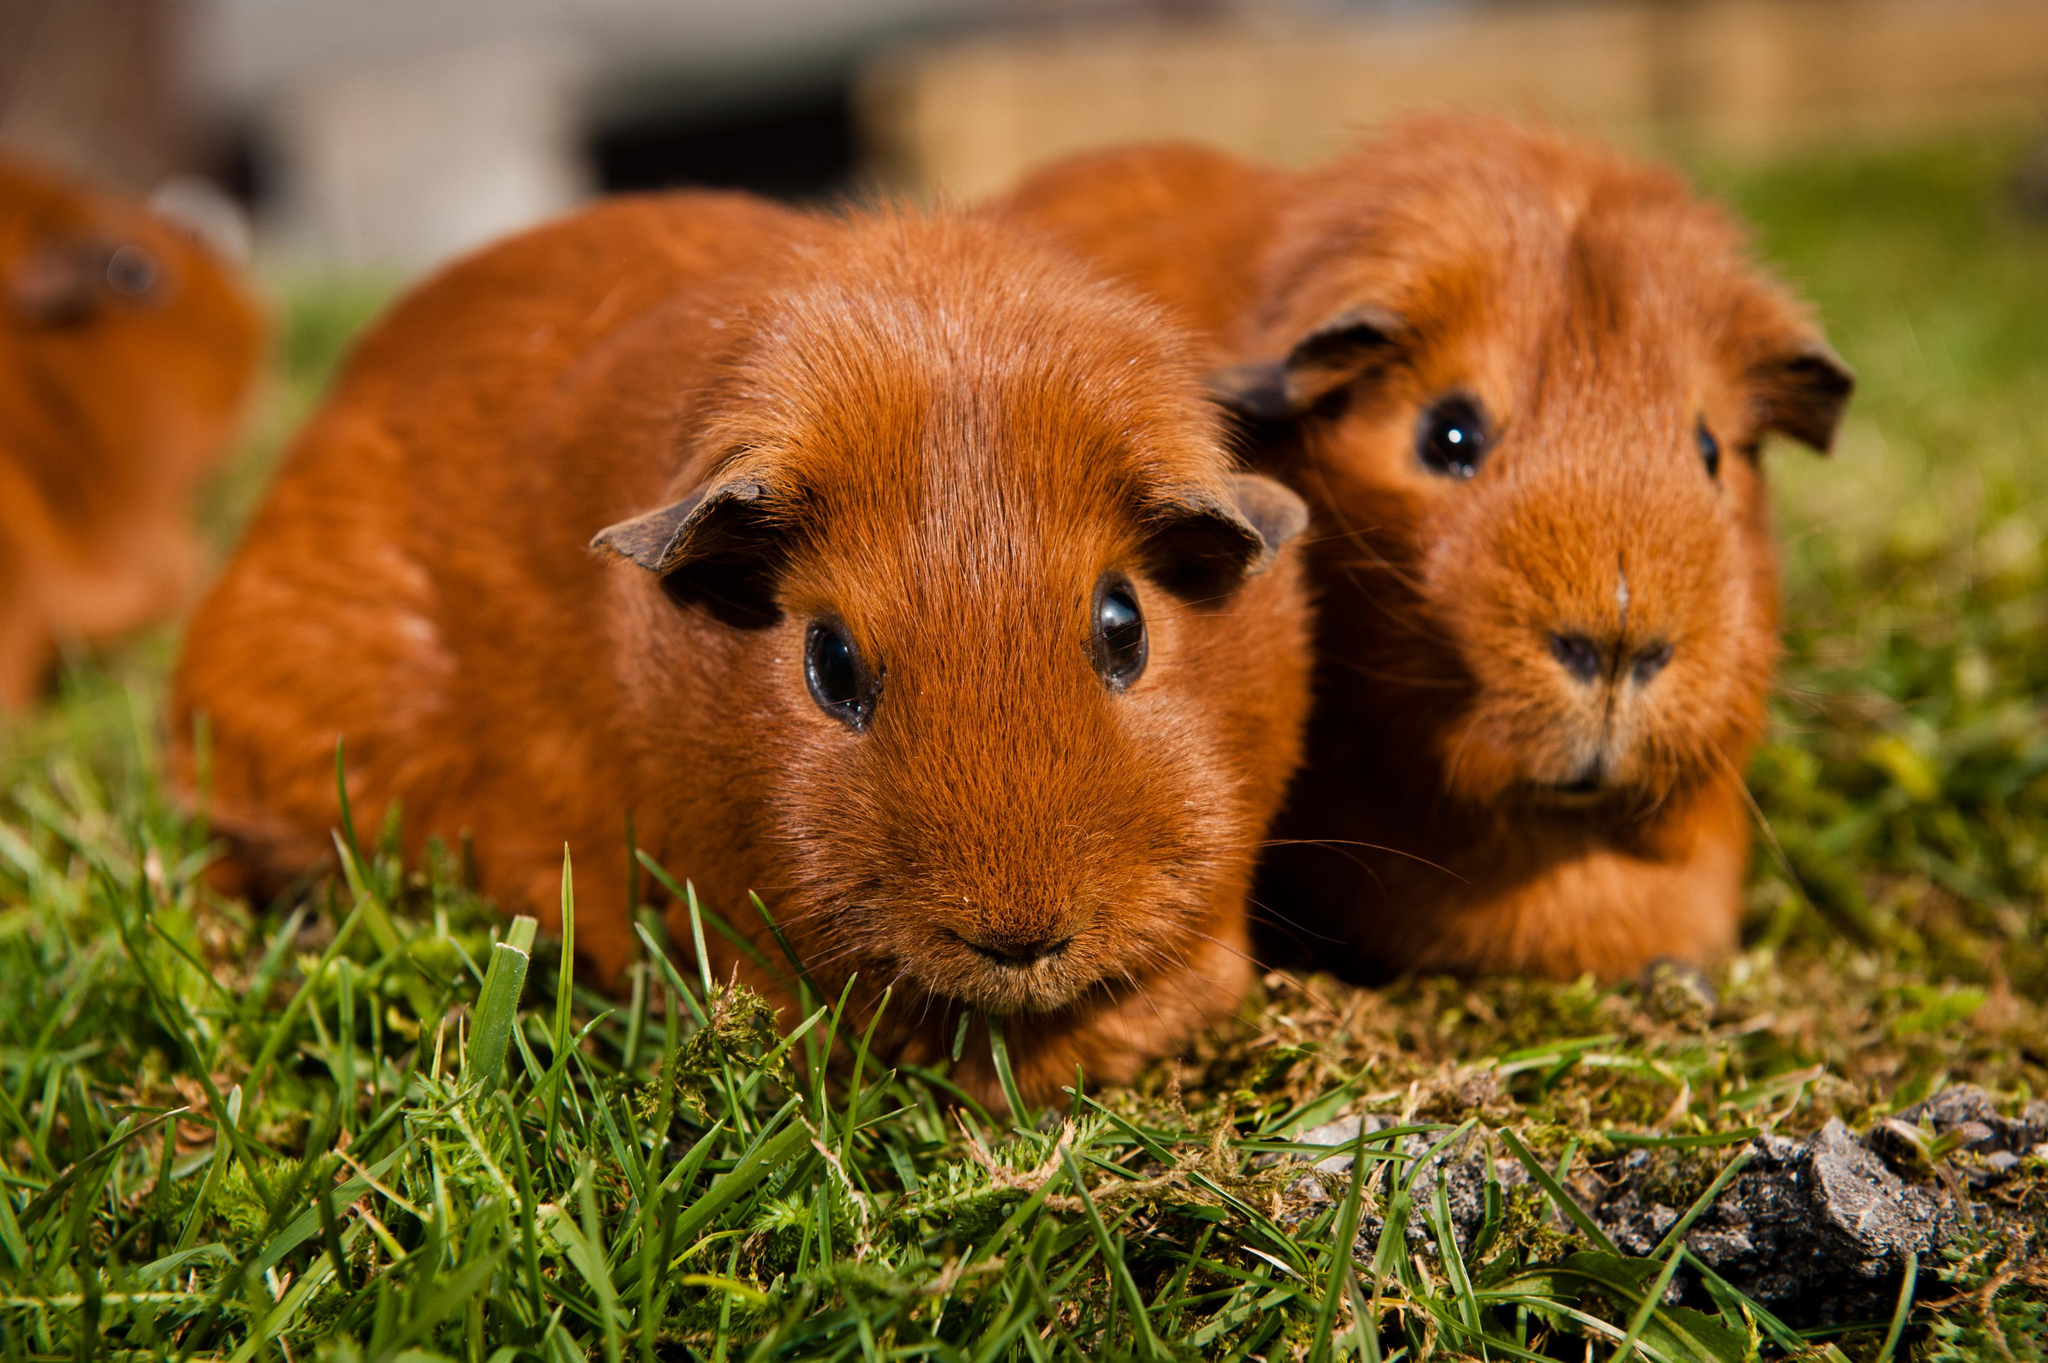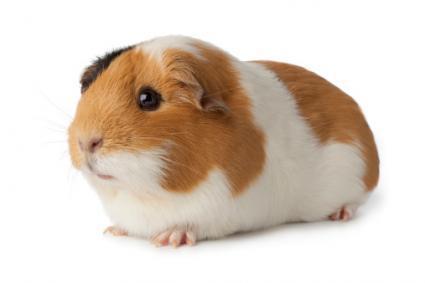The first image is the image on the left, the second image is the image on the right. Examine the images to the left and right. Is the description "there are exactly two animals in the image on the left" accurate? Answer yes or no. No. 